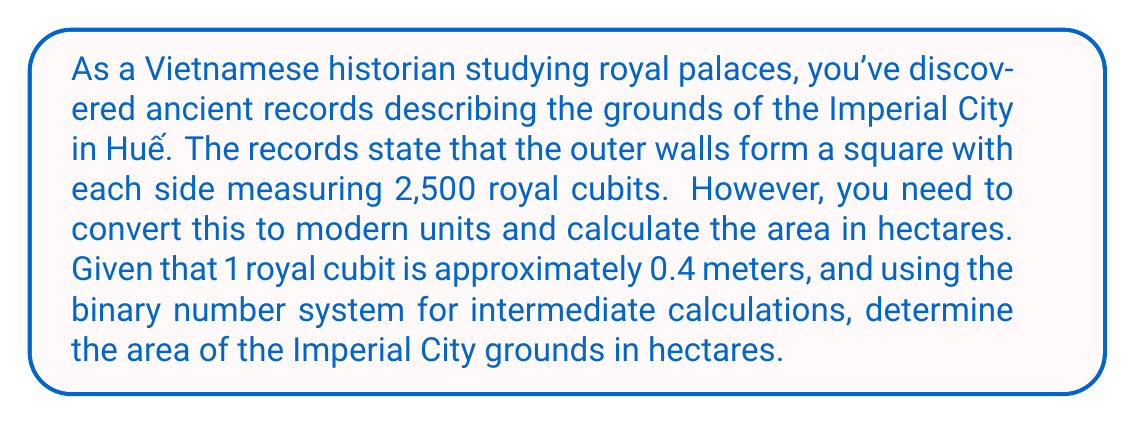Provide a solution to this math problem. Let's approach this problem step by step:

1. Convert royal cubits to meters:
   $2,500 \text{ royal cubits} \times 0.4 \text{ m/cubit} = 1,000 \text{ m}$

2. Convert 1,000 to binary:
   $1000_{10} = 1111101000_2$

3. Calculate the area in square meters using binary:
   $1111101000_2 \times 1111101000_2 = 11111010000000100000_2$

4. Convert the result back to decimal:
   $11111010000000100000_2 = 1,000,000_{10} \text{ m}^2$

5. Convert square meters to hectares:
   $$1 \text{ hectare} = 10,000 \text{ m}^2$$
   $$\frac{1,000,000 \text{ m}^2}{10,000 \text{ m}^2/\text{hectare}} = 100 \text{ hectares}$$

The use of the binary system for intermediate calculations demonstrates the versatility of different number systems in historical and mathematical contexts.
Answer: The area of the Imperial City grounds is 100 hectares. 